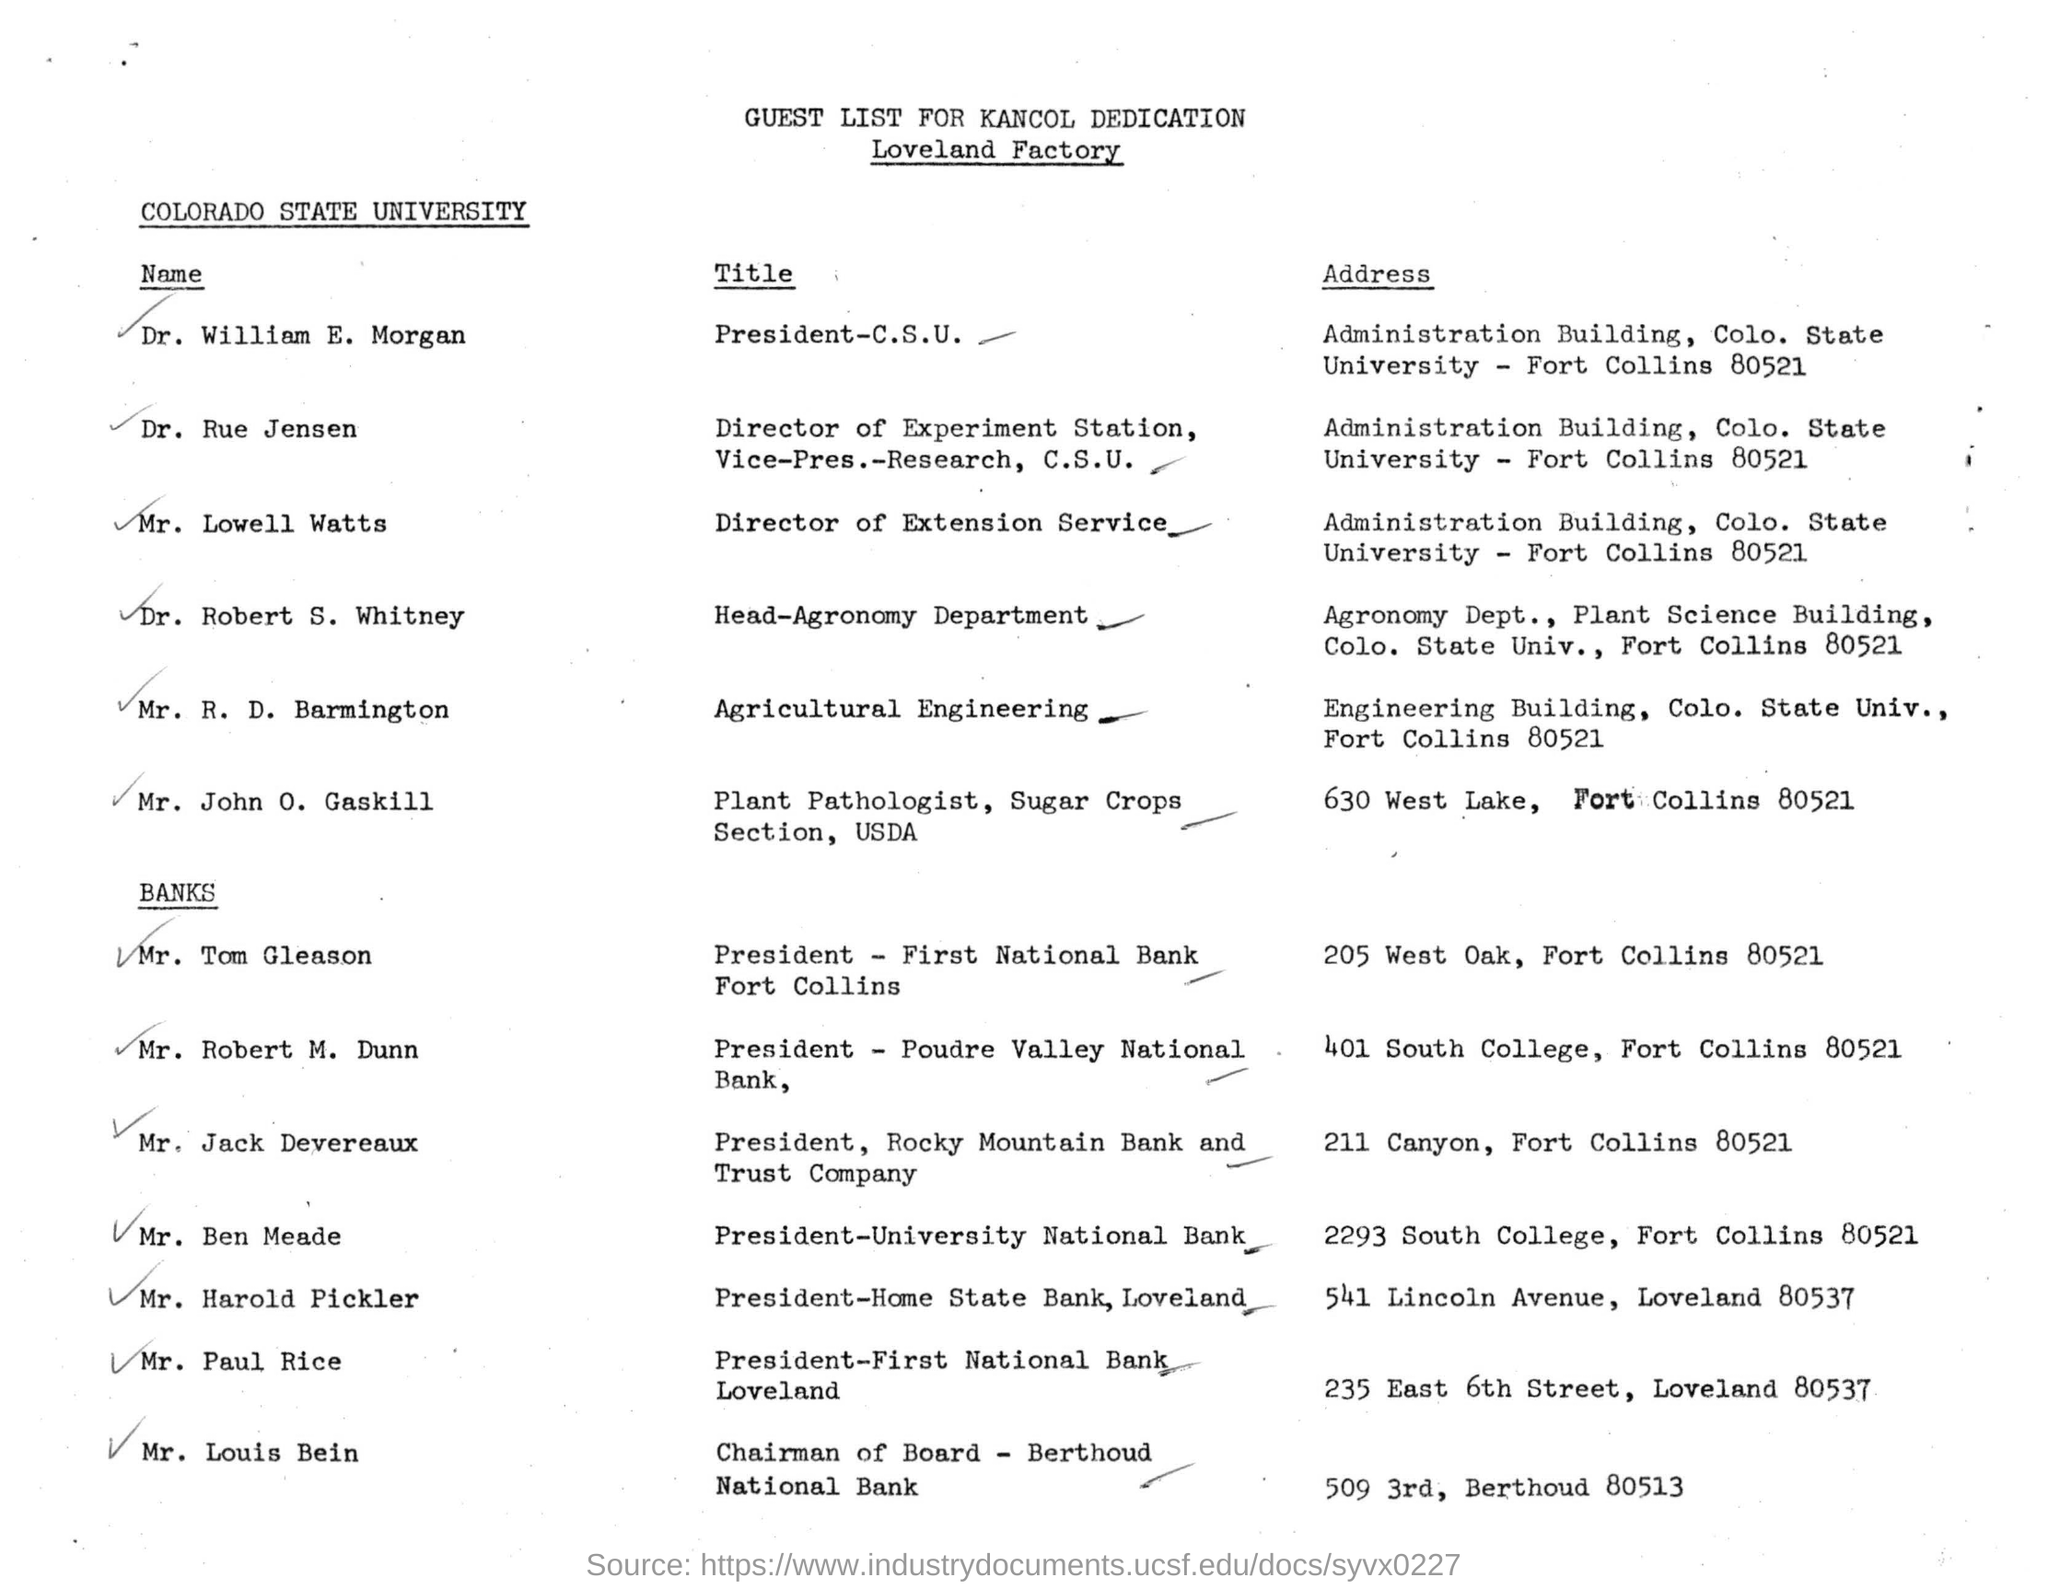What is the name of the university on the document?
Give a very brief answer. Colorado State University. Who is the president of first national bank fort collins?
Provide a short and direct response. Mr. Tom Gleason. What is the tilte of Dr. William E. Morgan?
Your answer should be very brief. President-C.S.U. 